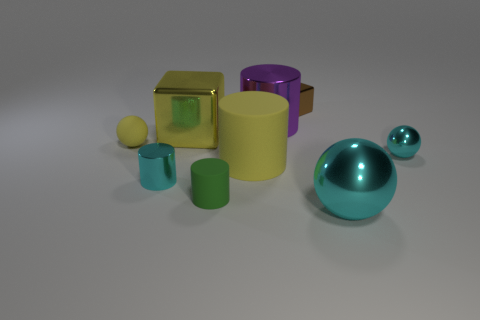Subtract all tiny shiny spheres. How many spheres are left? 2 Subtract all spheres. How many objects are left? 6 Subtract 4 cylinders. How many cylinders are left? 0 Subtract all green cylinders. How many cylinders are left? 3 Subtract all green cylinders. Subtract all purple spheres. How many cylinders are left? 3 Subtract all blue spheres. How many cyan blocks are left? 0 Subtract all purple shiny cylinders. Subtract all small cyan matte cubes. How many objects are left? 8 Add 9 tiny matte spheres. How many tiny matte spheres are left? 10 Add 7 metal cylinders. How many metal cylinders exist? 9 Subtract 1 cyan balls. How many objects are left? 8 